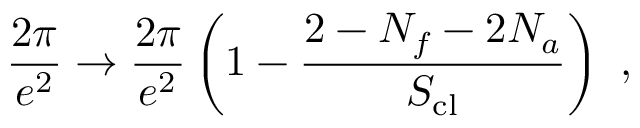Convert formula to latex. <formula><loc_0><loc_0><loc_500><loc_500>\frac { 2 \pi } { e ^ { 2 } } \rightarrow \frac { 2 \pi } { e ^ { 2 } } \left ( 1 - \frac { 2 - N _ { f } - 2 N _ { a } } { S _ { c l } } \right ) \ ,</formula> 